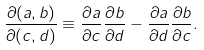<formula> <loc_0><loc_0><loc_500><loc_500>\frac { \partial ( a , b ) } { \partial ( c , d ) } \equiv \frac { \partial a } { \partial c } \frac { \partial b } { \partial d } - \frac { \partial a } { \partial d } \frac { \partial b } { \partial c } .</formula> 